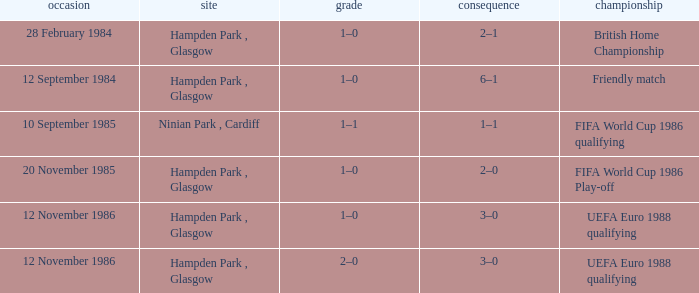What is the Score of the Fifa World Cup 1986 Play-off Competition? 1–0. 